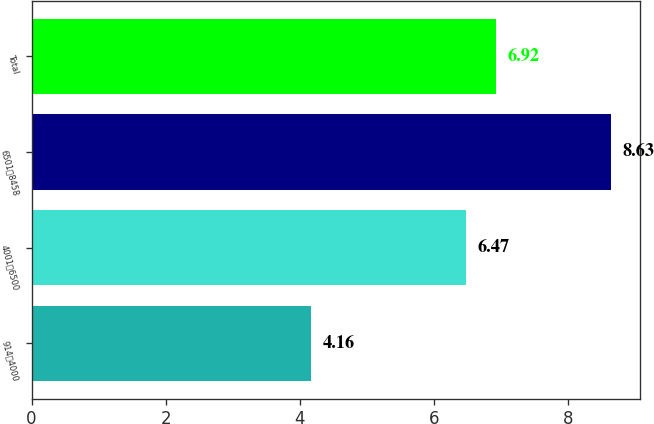Convert chart to OTSL. <chart><loc_0><loc_0><loc_500><loc_500><bar_chart><fcel>9144000<fcel>40016500<fcel>65018458<fcel>Total<nl><fcel>4.16<fcel>6.47<fcel>8.63<fcel>6.92<nl></chart> 